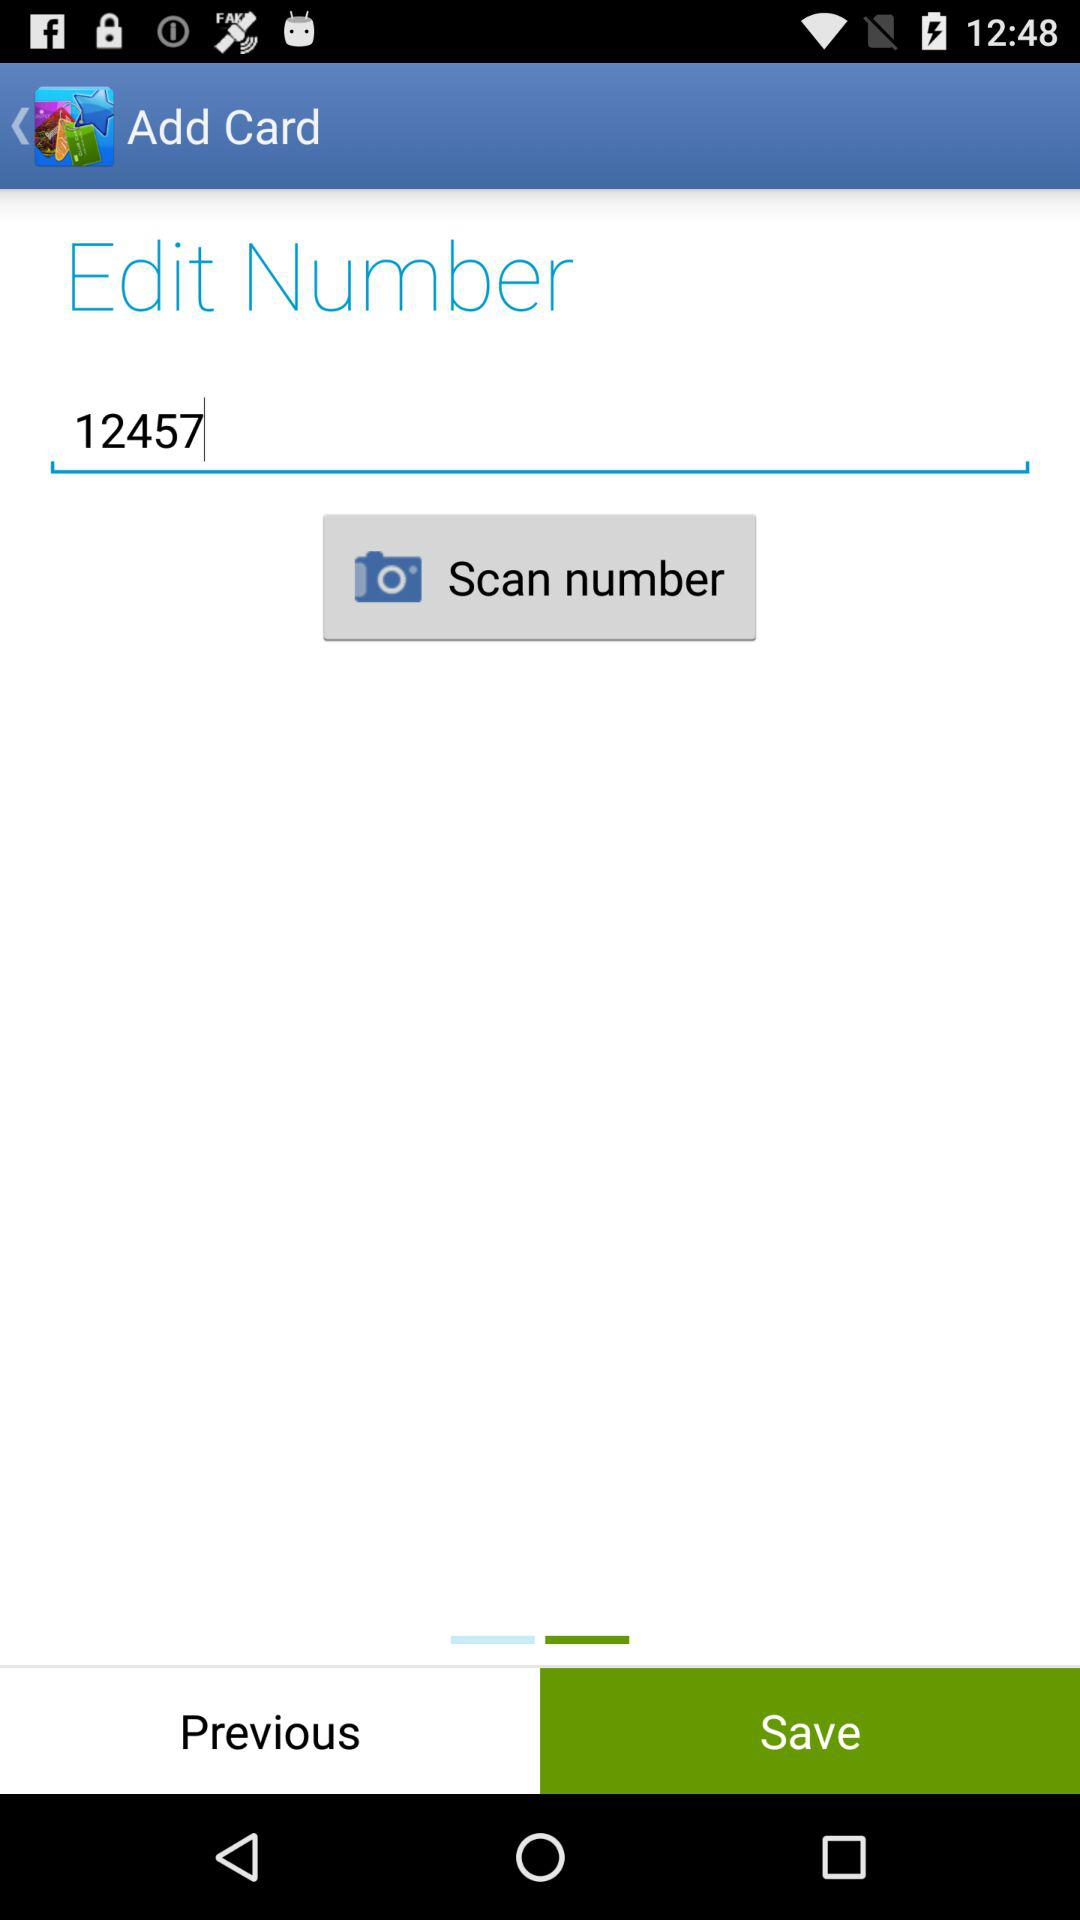What is the entered number? The entered number is 12457. 